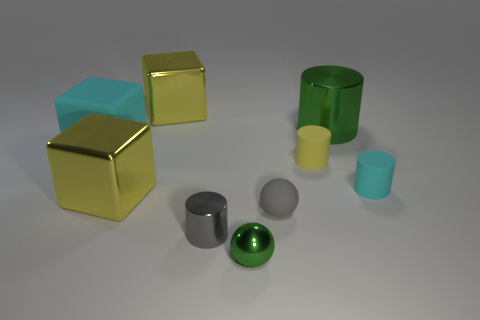What number of small rubber objects are the same color as the small metal cylinder?
Keep it short and to the point. 1. There is another object that is the same color as the big matte thing; what material is it?
Keep it short and to the point. Rubber. There is a yellow object that is the same shape as the big green metallic thing; what is it made of?
Offer a very short reply. Rubber. What number of other things are there of the same color as the tiny metal ball?
Give a very brief answer. 1. There is a rubber sphere; does it have the same color as the sphere that is in front of the gray metal thing?
Your response must be concise. No. There is a big thing right of the tiny gray sphere; how many big green shiny things are behind it?
Ensure brevity in your answer.  0. Is there any other thing that has the same material as the green sphere?
Make the answer very short. Yes. The ball in front of the tiny ball behind the small green metallic thing that is in front of the small gray matte sphere is made of what material?
Your answer should be very brief. Metal. There is a cylinder that is both to the right of the tiny yellow cylinder and in front of the big cyan block; what is its material?
Your response must be concise. Rubber. How many other things are the same shape as the gray shiny object?
Ensure brevity in your answer.  3. 